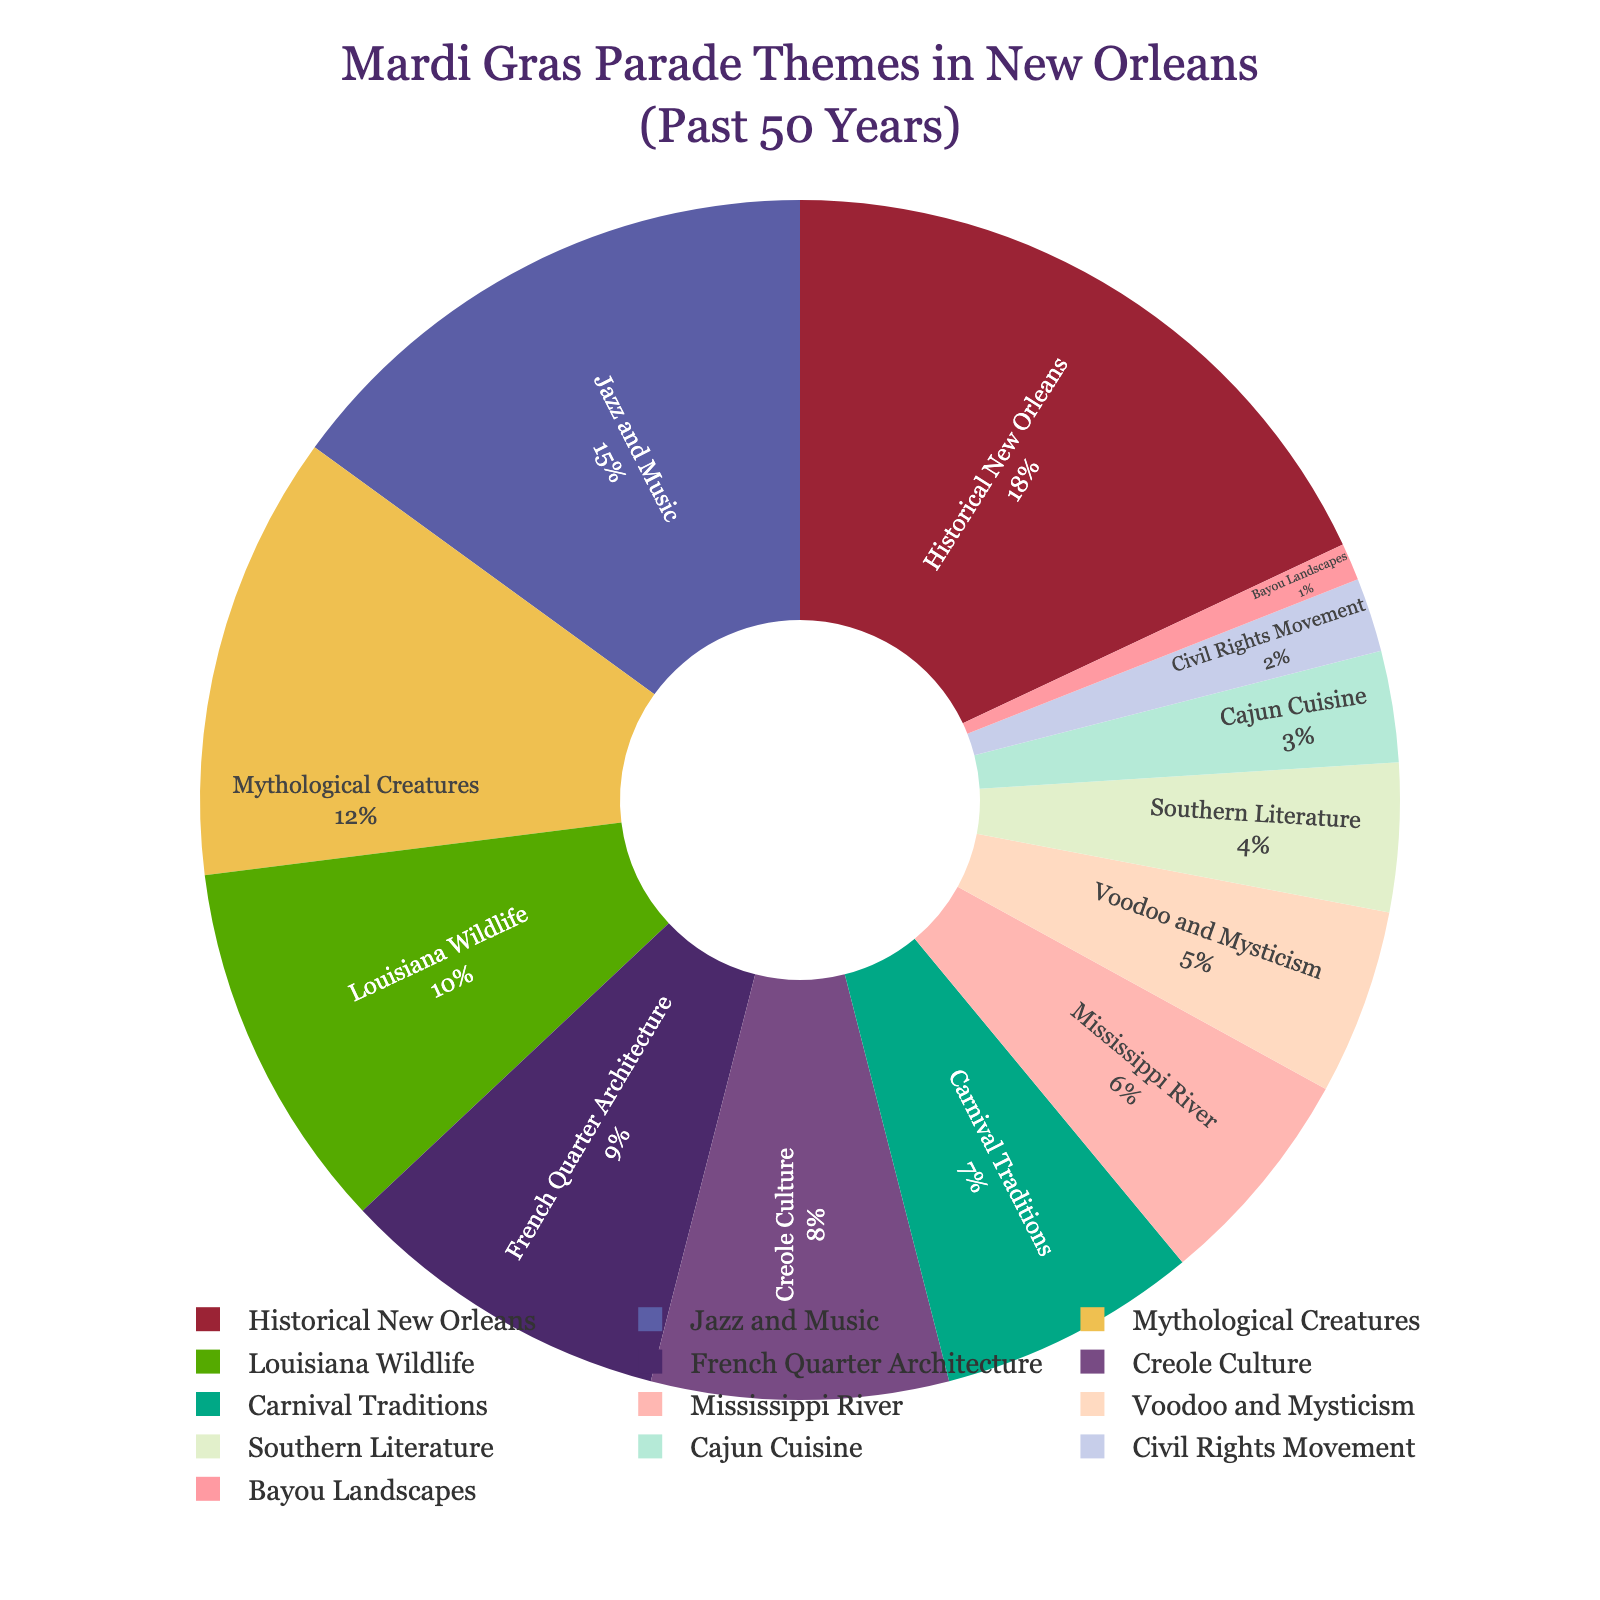Which Mardi Gras parade theme has the highest percentage? The theme with the highest percentage is the one with the largest segment in the pie chart. This is "Historical New Orleans" with 18%.
Answer: Historical New Orleans Which theme has the lowest representation among Mardi Gras parade themes? The theme with the smallest segment in the pie chart represents the lowest percentage. This is "Bayou Landscapes" with 1%.
Answer: Bayou Landscapes What is the combined percentage of the "Jazz and Music" and "Voodoo and Mysticism" themes? Add the percentages of "Jazz and Music" (15%) and "Voodoo and Mysticism" (5%). 15% + 5% = 20%.
Answer: 20% How much greater is the percentage of "Historical New Orleans" themes compared to "Cajun Cuisine" themes? Subtract the percentage of "Cajun Cuisine" (3%) from "Historical New Orleans" (18%). 18% - 3% = 15%.
Answer: 15% Which theme has a larger percentage: "Louisiana Wildlife" or "French Quarter Architecture"? Compare the segments for "Louisiana Wildlife" (10%) and "French Quarter Architecture" (9%). "Louisiana Wildlife" has a larger percentage.
Answer: Louisiana Wildlife What is the total percentage of themes related to culture ("Creole Culture" and "Carnival Traditions")? Add the percentages of "Creole Culture" (8%) and "Carnival Traditions" (7%). 8% + 7% = 15%.
Answer: 15% Is the percentage of "Southern Literature" themes greater than or equal to the percentage of "Cajun Cuisine" themes? Compare the percentages of "Southern Literature" (4%) and "Cajun Cuisine" (3%). "Southern Literature" is greater.
Answer: Yes What is the difference in percentage between "Historical New Orleans" and "Southern Literature" themes? Subtract the percentage of "Southern Literature" (4%) from "Historical New Orleans" (18%). 18% - 4% = 14%.
Answer: 14% How much greater is the percentage of "French Quarter Architecture" themes compared to "Bayou Landscapes" themes? Subtract the percentage of "Bayou Landscapes" (1%) from "French Quarter Architecture" (9%). 9% - 1% = 8%.
Answer: 8% What is the combined percentage of the least three represented themes? Add the percentages of "Southern Literature" (4%), "Cajun Cuisine" (3%), and "Bayou Landscapes" (1%). 4% + 3% + 1% = 8%.
Answer: 8% 